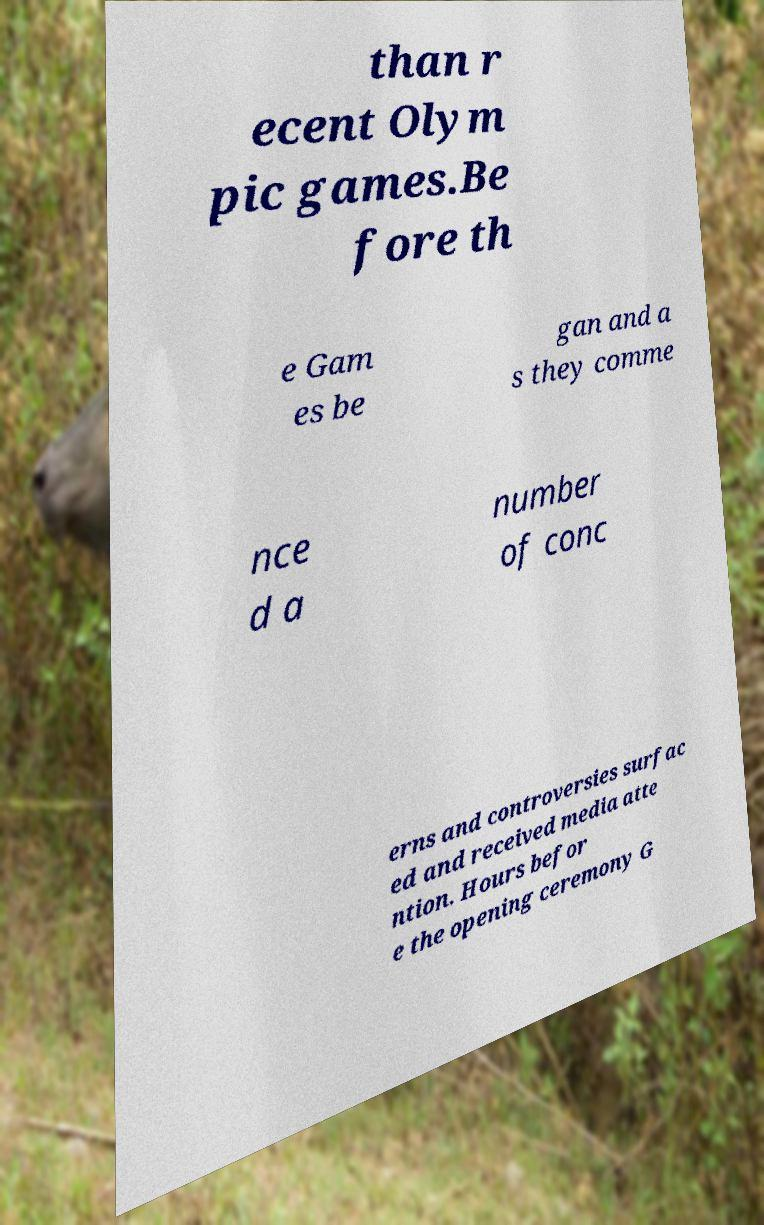I need the written content from this picture converted into text. Can you do that? than r ecent Olym pic games.Be fore th e Gam es be gan and a s they comme nce d a number of conc erns and controversies surfac ed and received media atte ntion. Hours befor e the opening ceremony G 